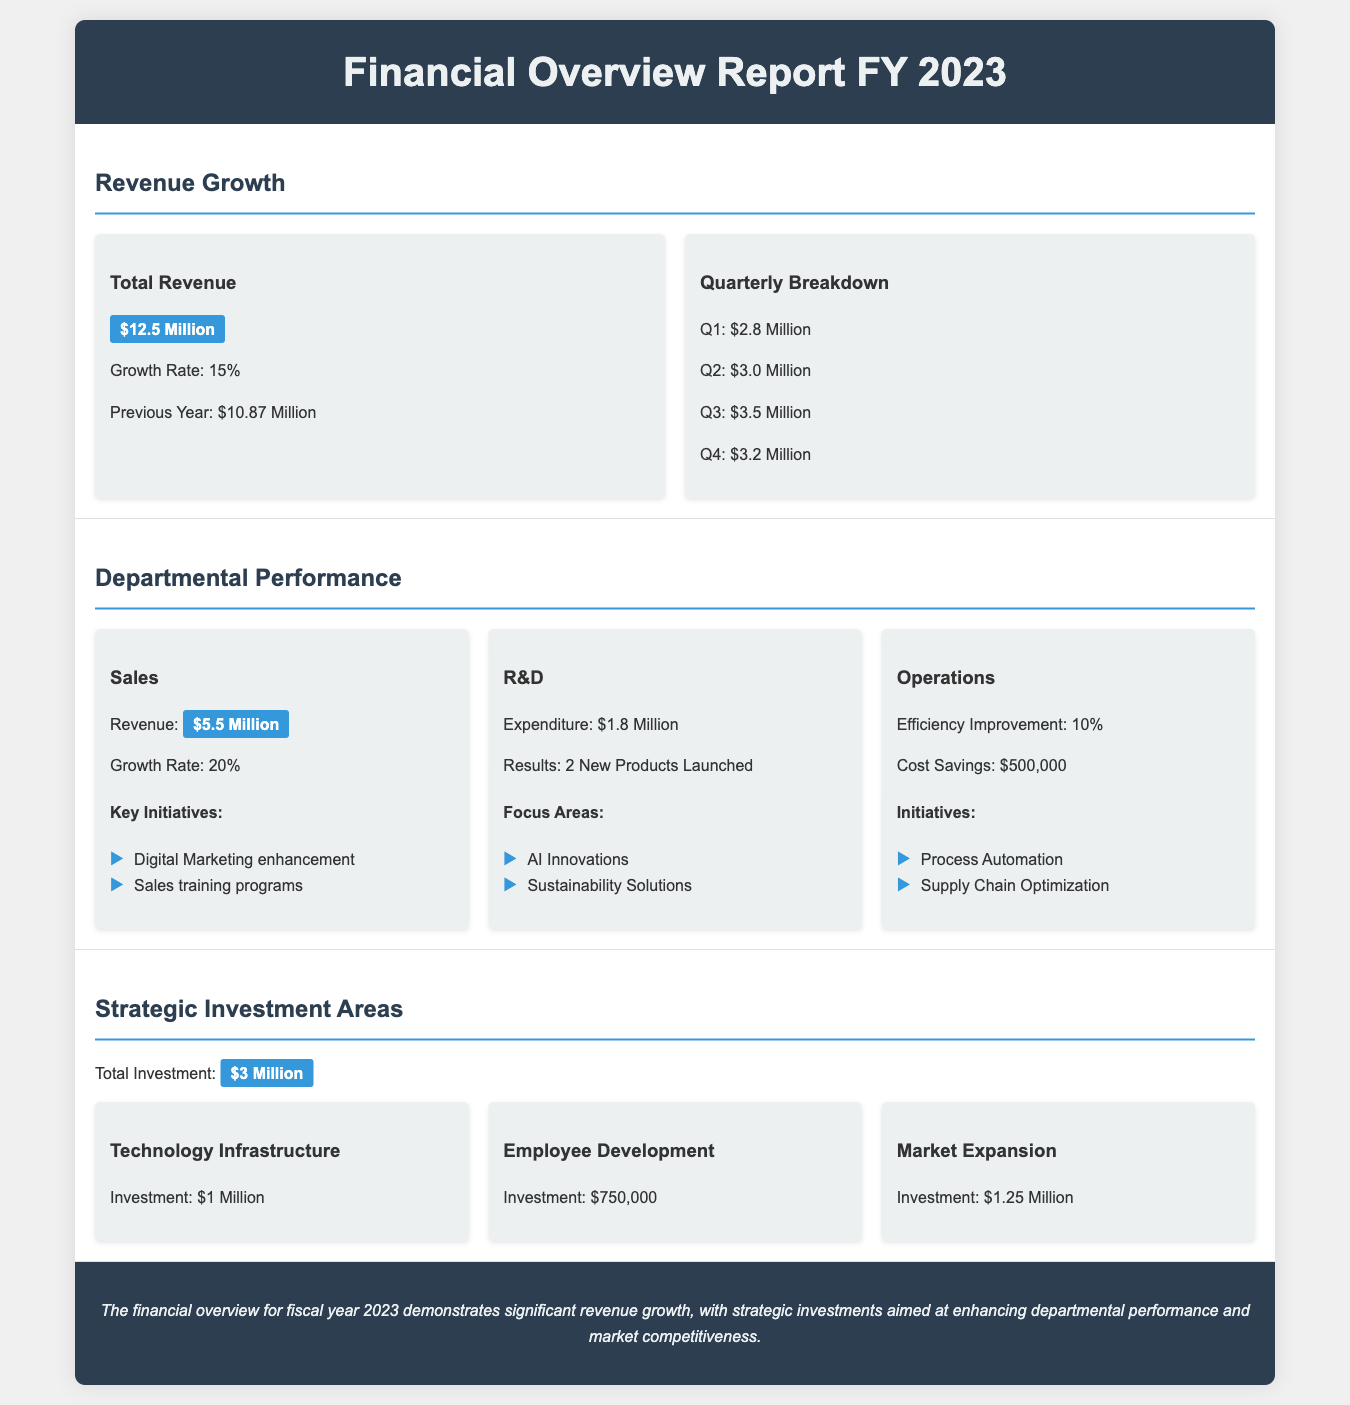What is the total revenue for FY 2023? The total revenue is stated clearly in the report as $12.5 Million.
Answer: $12.5 Million What was the growth rate of total revenue? The growth rate of total revenue is given in the report as 15%.
Answer: 15% How much did the Sales department earn? The revenue earned by the Sales department is highlighted as $5.5 Million.
Answer: $5.5 Million What was the expenditure for R&D? The R&D expenditure is mentioned as $1.8 Million in the document.
Answer: $1.8 Million How many new products were launched by the R&D department? The report states that the R&D department launched 2 new products.
Answer: 2 What is the total investment in strategic areas? The total investment across strategic areas is specified as $3 Million.
Answer: $3 Million Which department had a growth rate of 20%? The Sales department achieved a growth rate of 20%.
Answer: Sales How much was invested in Technology Infrastructure? The investment allocated for Technology Infrastructure is listed as $1 Million.
Answer: $1 Million What was the efficiency improvement achieved by Operations? Operations achieved an efficiency improvement of 10%.
Answer: 10% 